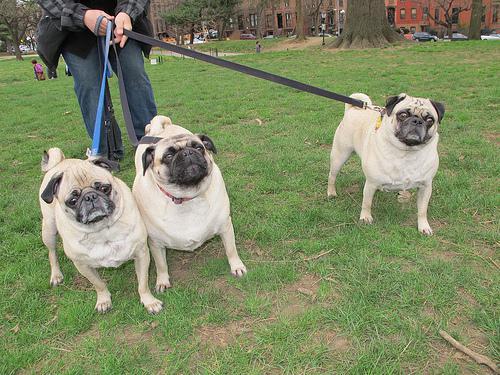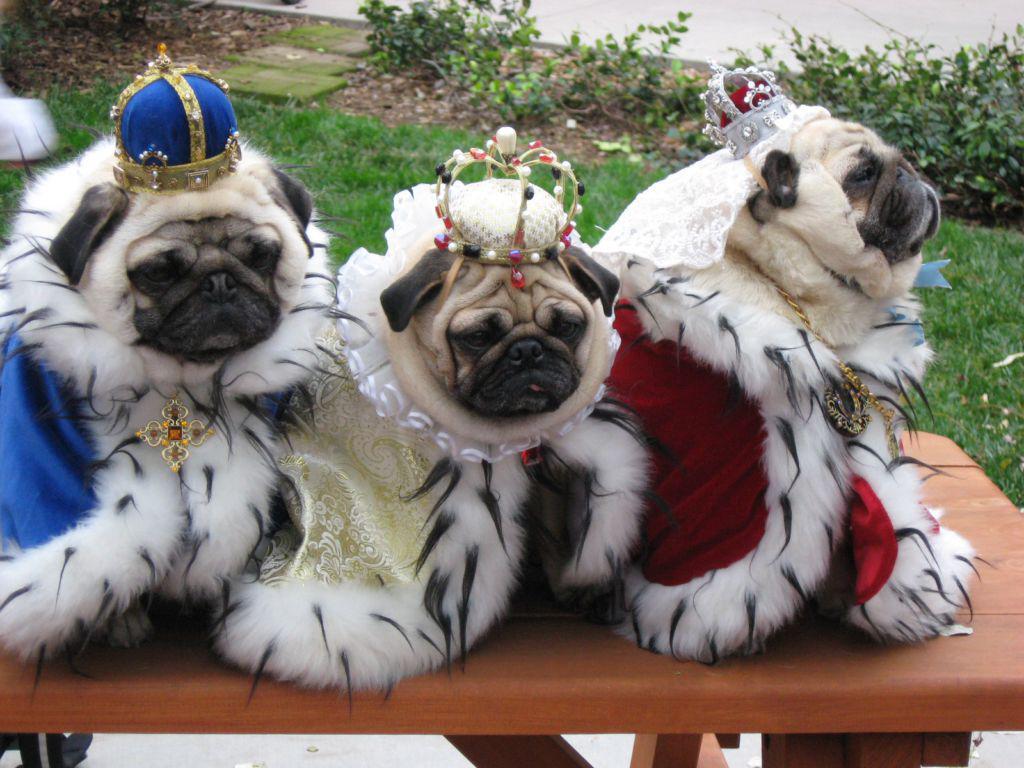The first image is the image on the left, the second image is the image on the right. Given the left and right images, does the statement "The right image contains three pug dogs." hold true? Answer yes or no. Yes. 